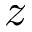<formula> <loc_0><loc_0><loc_500><loc_500>z</formula> 